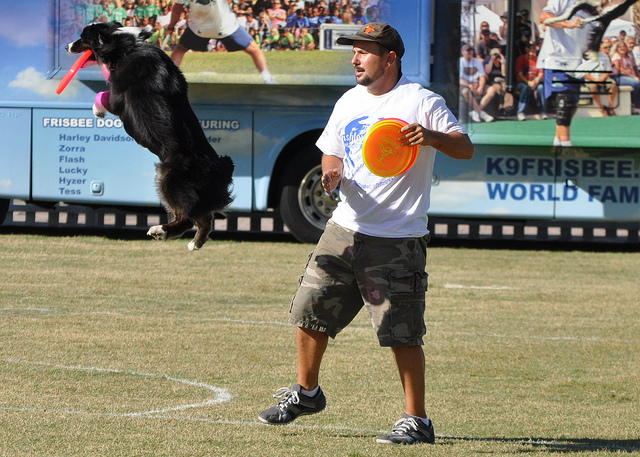What kind of training might this dog have undergone to perform like this? This dog has probably undergone significant agility and obedience training, which includes learning to follow commands, improving reaction times, and enhancing physical fitness. Additionally, training for disc catching specifically hones the dog's ability to time jumps and accurately catch the Frisbee. 